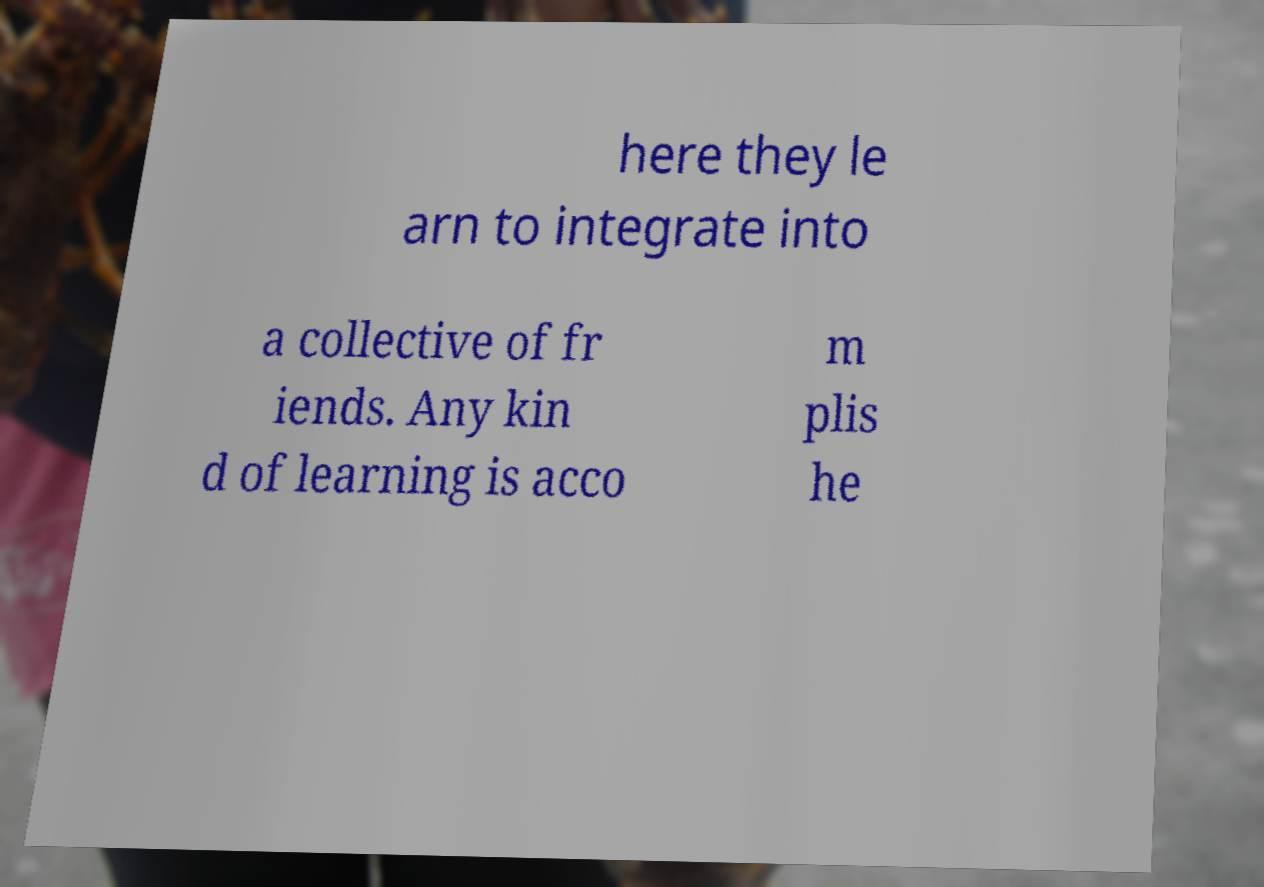Can you read and provide the text displayed in the image?This photo seems to have some interesting text. Can you extract and type it out for me? here they le arn to integrate into a collective of fr iends. Any kin d of learning is acco m plis he 